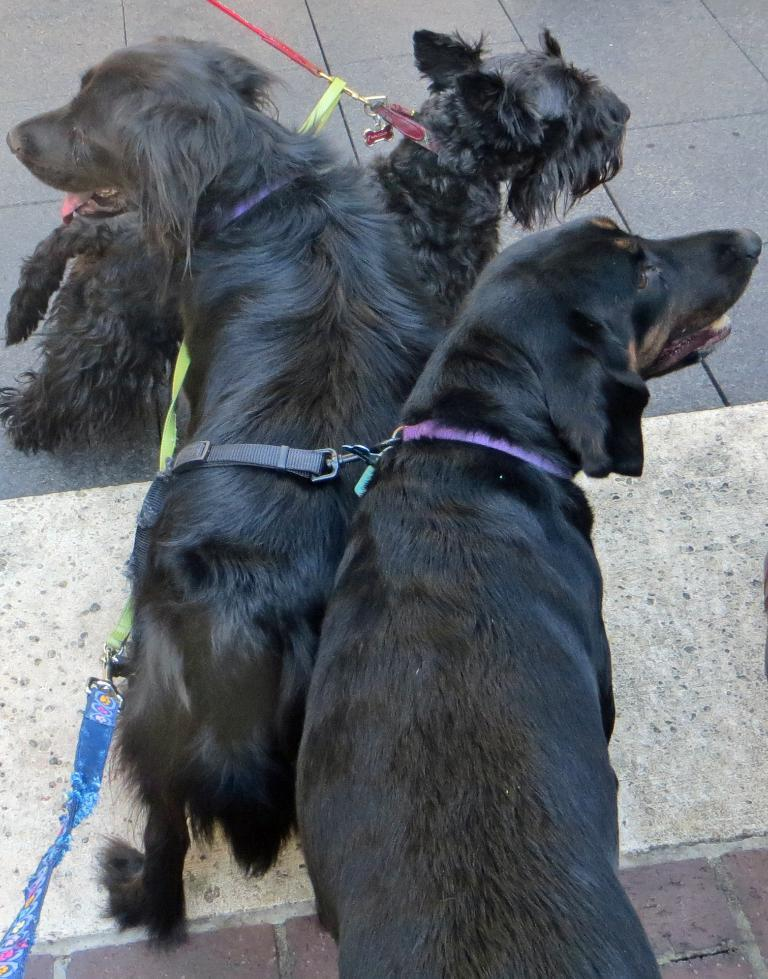How many dogs are in the image? There are three black dogs in the image. What is attached to each dog? Each dog has a leash. What color is the glass of orange juice on the table in the image? There is no glass of orange juice or table present in the image; it only features three black dogs with leashes. 